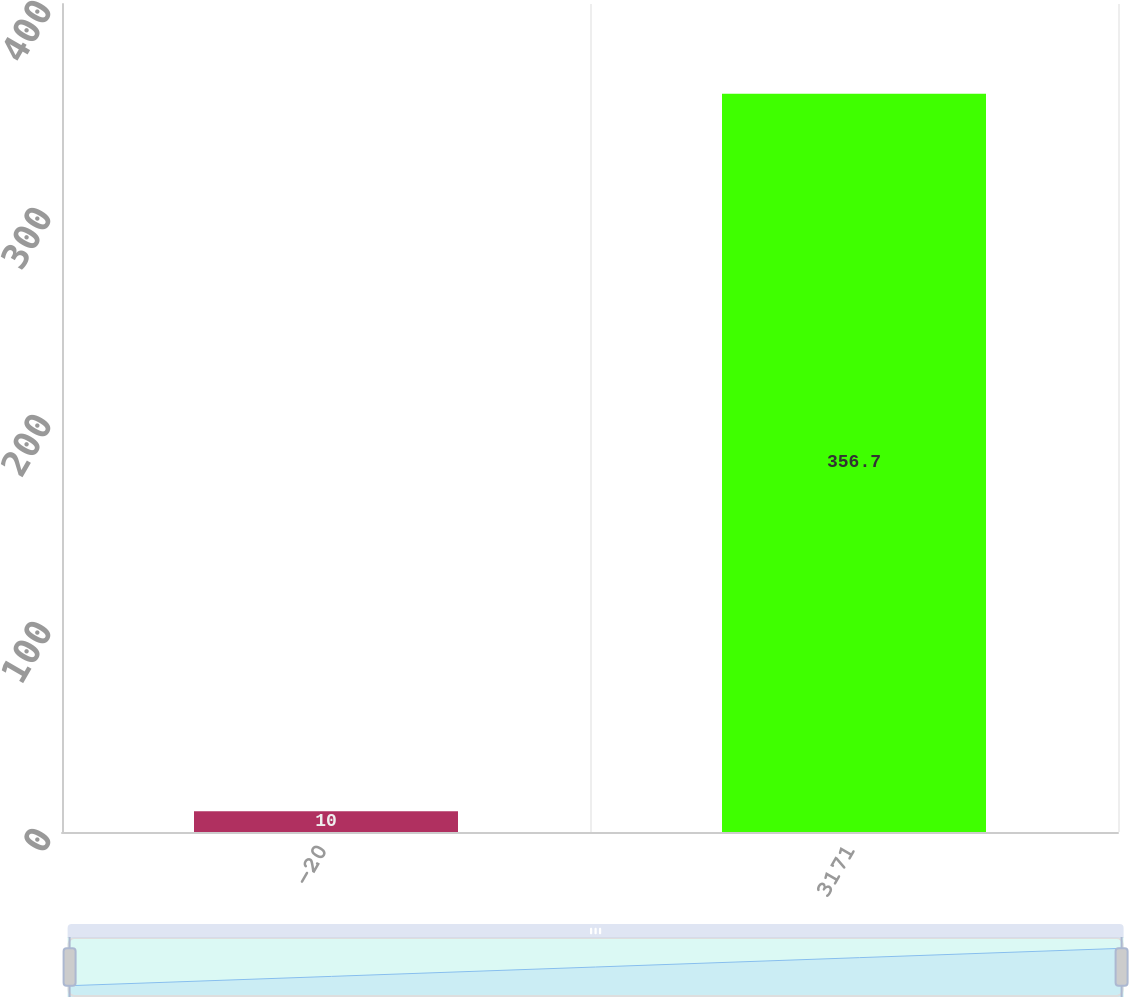<chart> <loc_0><loc_0><loc_500><loc_500><bar_chart><fcel>-20<fcel>3171<nl><fcel>10<fcel>356.7<nl></chart> 